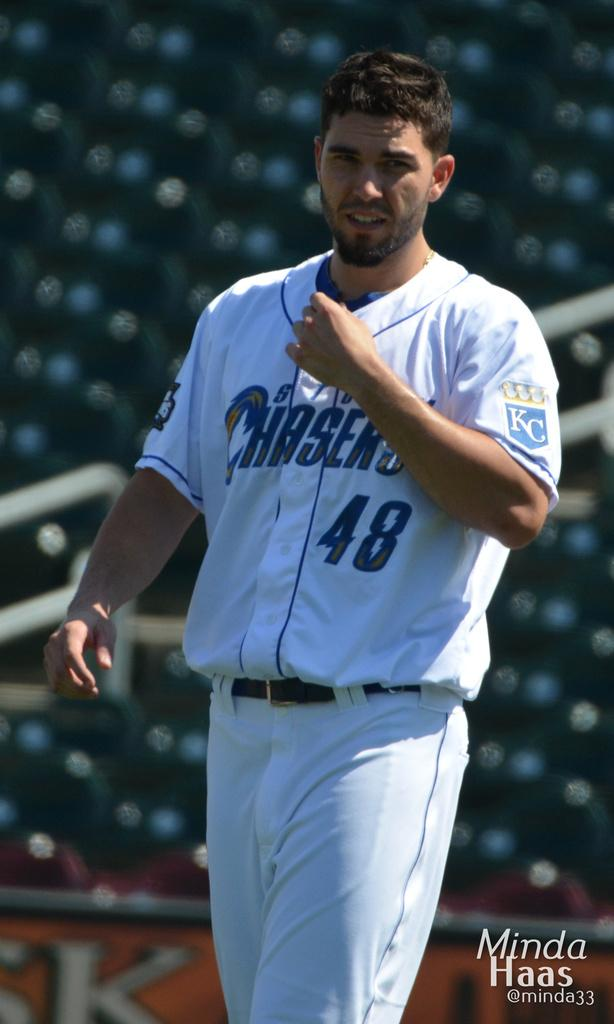What is the man in the image doing? The man is standing in the image. What is the man wearing? The man is wearing a white shirt and a pant. Which direction is the man looking? The man is looking to the left. What can be seen on the image besides the man? There is a logo on the image, and the backdrop is blurred. What type of jellyfish can be seen swimming in the image? There is no jellyfish present in the image; it features a man standing and looking to the left. How many stamps are visible on the man's shirt in the image? There is no stamp visible on the man's shirt in the image; he is wearing a plain white shirt. 